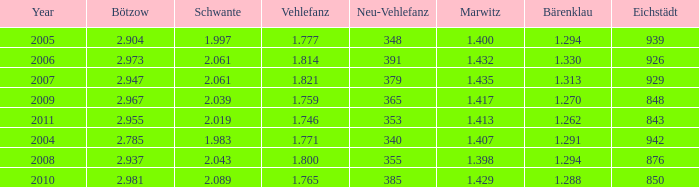What year has a Schwante smaller than 2.043, an Eichstädt smaller than 848, and a Bärenklau smaller than 1.262? 0.0. 